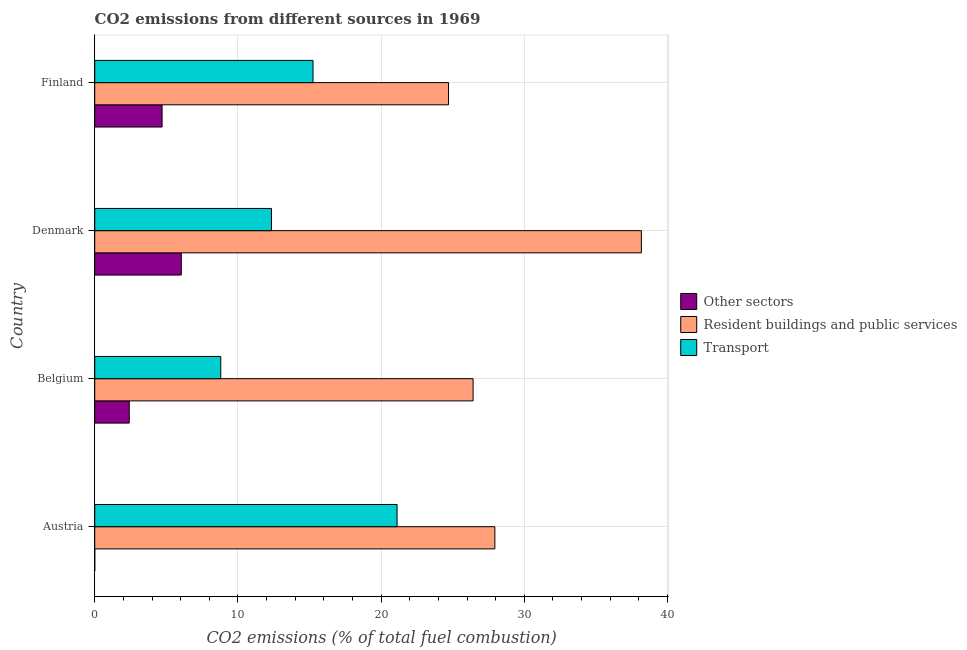How many different coloured bars are there?
Provide a short and direct response. 3. How many groups of bars are there?
Offer a very short reply. 4. What is the label of the 1st group of bars from the top?
Give a very brief answer. Finland. In how many cases, is the number of bars for a given country not equal to the number of legend labels?
Your answer should be compact. 1. What is the percentage of co2 emissions from other sectors in Finland?
Give a very brief answer. 4.7. Across all countries, what is the maximum percentage of co2 emissions from resident buildings and public services?
Make the answer very short. 38.18. Across all countries, what is the minimum percentage of co2 emissions from other sectors?
Offer a terse response. 0. What is the total percentage of co2 emissions from transport in the graph?
Your answer should be very brief. 57.51. What is the difference between the percentage of co2 emissions from resident buildings and public services in Denmark and that in Finland?
Your answer should be compact. 13.47. What is the difference between the percentage of co2 emissions from transport in Austria and the percentage of co2 emissions from resident buildings and public services in Denmark?
Keep it short and to the point. -17.06. What is the average percentage of co2 emissions from other sectors per country?
Provide a succinct answer. 3.29. What is the difference between the percentage of co2 emissions from other sectors and percentage of co2 emissions from resident buildings and public services in Belgium?
Ensure brevity in your answer.  -24.01. In how many countries, is the percentage of co2 emissions from other sectors greater than 26 %?
Offer a terse response. 0. What is the ratio of the percentage of co2 emissions from resident buildings and public services in Austria to that in Finland?
Ensure brevity in your answer.  1.13. Is the percentage of co2 emissions from transport in Austria less than that in Finland?
Make the answer very short. No. What is the difference between the highest and the second highest percentage of co2 emissions from other sectors?
Your response must be concise. 1.34. What is the difference between the highest and the lowest percentage of co2 emissions from resident buildings and public services?
Give a very brief answer. 13.47. In how many countries, is the percentage of co2 emissions from resident buildings and public services greater than the average percentage of co2 emissions from resident buildings and public services taken over all countries?
Your answer should be compact. 1. Is the sum of the percentage of co2 emissions from resident buildings and public services in Denmark and Finland greater than the maximum percentage of co2 emissions from transport across all countries?
Your response must be concise. Yes. Is it the case that in every country, the sum of the percentage of co2 emissions from other sectors and percentage of co2 emissions from resident buildings and public services is greater than the percentage of co2 emissions from transport?
Keep it short and to the point. Yes. How many bars are there?
Your response must be concise. 11. Are all the bars in the graph horizontal?
Provide a short and direct response. Yes. Are the values on the major ticks of X-axis written in scientific E-notation?
Provide a short and direct response. No. Does the graph contain any zero values?
Offer a very short reply. Yes. Does the graph contain grids?
Make the answer very short. Yes. Where does the legend appear in the graph?
Make the answer very short. Center right. What is the title of the graph?
Your answer should be very brief. CO2 emissions from different sources in 1969. What is the label or title of the X-axis?
Offer a very short reply. CO2 emissions (% of total fuel combustion). What is the label or title of the Y-axis?
Your answer should be compact. Country. What is the CO2 emissions (% of total fuel combustion) in Other sectors in Austria?
Make the answer very short. 0. What is the CO2 emissions (% of total fuel combustion) in Resident buildings and public services in Austria?
Your response must be concise. 27.94. What is the CO2 emissions (% of total fuel combustion) in Transport in Austria?
Offer a very short reply. 21.11. What is the CO2 emissions (% of total fuel combustion) in Other sectors in Belgium?
Offer a terse response. 2.41. What is the CO2 emissions (% of total fuel combustion) of Resident buildings and public services in Belgium?
Your answer should be compact. 26.42. What is the CO2 emissions (% of total fuel combustion) of Transport in Belgium?
Make the answer very short. 8.8. What is the CO2 emissions (% of total fuel combustion) in Other sectors in Denmark?
Offer a terse response. 6.05. What is the CO2 emissions (% of total fuel combustion) in Resident buildings and public services in Denmark?
Your response must be concise. 38.18. What is the CO2 emissions (% of total fuel combustion) of Transport in Denmark?
Keep it short and to the point. 12.34. What is the CO2 emissions (% of total fuel combustion) in Other sectors in Finland?
Offer a terse response. 4.7. What is the CO2 emissions (% of total fuel combustion) of Resident buildings and public services in Finland?
Give a very brief answer. 24.71. What is the CO2 emissions (% of total fuel combustion) in Transport in Finland?
Give a very brief answer. 15.25. Across all countries, what is the maximum CO2 emissions (% of total fuel combustion) in Other sectors?
Your response must be concise. 6.05. Across all countries, what is the maximum CO2 emissions (% of total fuel combustion) of Resident buildings and public services?
Provide a short and direct response. 38.18. Across all countries, what is the maximum CO2 emissions (% of total fuel combustion) of Transport?
Keep it short and to the point. 21.11. Across all countries, what is the minimum CO2 emissions (% of total fuel combustion) in Resident buildings and public services?
Ensure brevity in your answer.  24.71. Across all countries, what is the minimum CO2 emissions (% of total fuel combustion) of Transport?
Your response must be concise. 8.8. What is the total CO2 emissions (% of total fuel combustion) in Other sectors in the graph?
Keep it short and to the point. 13.16. What is the total CO2 emissions (% of total fuel combustion) in Resident buildings and public services in the graph?
Give a very brief answer. 117.26. What is the total CO2 emissions (% of total fuel combustion) of Transport in the graph?
Your answer should be very brief. 57.51. What is the difference between the CO2 emissions (% of total fuel combustion) of Resident buildings and public services in Austria and that in Belgium?
Keep it short and to the point. 1.52. What is the difference between the CO2 emissions (% of total fuel combustion) in Transport in Austria and that in Belgium?
Provide a short and direct response. 12.31. What is the difference between the CO2 emissions (% of total fuel combustion) in Resident buildings and public services in Austria and that in Denmark?
Your response must be concise. -10.23. What is the difference between the CO2 emissions (% of total fuel combustion) in Transport in Austria and that in Denmark?
Offer a very short reply. 8.77. What is the difference between the CO2 emissions (% of total fuel combustion) of Resident buildings and public services in Austria and that in Finland?
Ensure brevity in your answer.  3.23. What is the difference between the CO2 emissions (% of total fuel combustion) in Transport in Austria and that in Finland?
Make the answer very short. 5.87. What is the difference between the CO2 emissions (% of total fuel combustion) in Other sectors in Belgium and that in Denmark?
Offer a very short reply. -3.63. What is the difference between the CO2 emissions (% of total fuel combustion) of Resident buildings and public services in Belgium and that in Denmark?
Provide a succinct answer. -11.75. What is the difference between the CO2 emissions (% of total fuel combustion) in Transport in Belgium and that in Denmark?
Make the answer very short. -3.54. What is the difference between the CO2 emissions (% of total fuel combustion) in Other sectors in Belgium and that in Finland?
Provide a succinct answer. -2.29. What is the difference between the CO2 emissions (% of total fuel combustion) in Resident buildings and public services in Belgium and that in Finland?
Your answer should be very brief. 1.72. What is the difference between the CO2 emissions (% of total fuel combustion) of Transport in Belgium and that in Finland?
Offer a very short reply. -6.44. What is the difference between the CO2 emissions (% of total fuel combustion) of Other sectors in Denmark and that in Finland?
Ensure brevity in your answer.  1.34. What is the difference between the CO2 emissions (% of total fuel combustion) of Resident buildings and public services in Denmark and that in Finland?
Your answer should be compact. 13.47. What is the difference between the CO2 emissions (% of total fuel combustion) in Transport in Denmark and that in Finland?
Make the answer very short. -2.9. What is the difference between the CO2 emissions (% of total fuel combustion) in Resident buildings and public services in Austria and the CO2 emissions (% of total fuel combustion) in Transport in Belgium?
Offer a terse response. 19.14. What is the difference between the CO2 emissions (% of total fuel combustion) in Resident buildings and public services in Austria and the CO2 emissions (% of total fuel combustion) in Transport in Denmark?
Your answer should be compact. 15.6. What is the difference between the CO2 emissions (% of total fuel combustion) in Resident buildings and public services in Austria and the CO2 emissions (% of total fuel combustion) in Transport in Finland?
Ensure brevity in your answer.  12.7. What is the difference between the CO2 emissions (% of total fuel combustion) in Other sectors in Belgium and the CO2 emissions (% of total fuel combustion) in Resident buildings and public services in Denmark?
Your answer should be compact. -35.77. What is the difference between the CO2 emissions (% of total fuel combustion) of Other sectors in Belgium and the CO2 emissions (% of total fuel combustion) of Transport in Denmark?
Your answer should be very brief. -9.93. What is the difference between the CO2 emissions (% of total fuel combustion) in Resident buildings and public services in Belgium and the CO2 emissions (% of total fuel combustion) in Transport in Denmark?
Provide a succinct answer. 14.08. What is the difference between the CO2 emissions (% of total fuel combustion) of Other sectors in Belgium and the CO2 emissions (% of total fuel combustion) of Resident buildings and public services in Finland?
Provide a succinct answer. -22.3. What is the difference between the CO2 emissions (% of total fuel combustion) of Other sectors in Belgium and the CO2 emissions (% of total fuel combustion) of Transport in Finland?
Your answer should be compact. -12.84. What is the difference between the CO2 emissions (% of total fuel combustion) of Resident buildings and public services in Belgium and the CO2 emissions (% of total fuel combustion) of Transport in Finland?
Your answer should be very brief. 11.18. What is the difference between the CO2 emissions (% of total fuel combustion) in Other sectors in Denmark and the CO2 emissions (% of total fuel combustion) in Resident buildings and public services in Finland?
Your response must be concise. -18.66. What is the difference between the CO2 emissions (% of total fuel combustion) of Other sectors in Denmark and the CO2 emissions (% of total fuel combustion) of Transport in Finland?
Provide a succinct answer. -9.2. What is the difference between the CO2 emissions (% of total fuel combustion) in Resident buildings and public services in Denmark and the CO2 emissions (% of total fuel combustion) in Transport in Finland?
Offer a terse response. 22.93. What is the average CO2 emissions (% of total fuel combustion) in Other sectors per country?
Provide a short and direct response. 3.29. What is the average CO2 emissions (% of total fuel combustion) of Resident buildings and public services per country?
Your answer should be very brief. 29.31. What is the average CO2 emissions (% of total fuel combustion) of Transport per country?
Give a very brief answer. 14.38. What is the difference between the CO2 emissions (% of total fuel combustion) of Resident buildings and public services and CO2 emissions (% of total fuel combustion) of Transport in Austria?
Keep it short and to the point. 6.83. What is the difference between the CO2 emissions (% of total fuel combustion) in Other sectors and CO2 emissions (% of total fuel combustion) in Resident buildings and public services in Belgium?
Your answer should be very brief. -24.01. What is the difference between the CO2 emissions (% of total fuel combustion) in Other sectors and CO2 emissions (% of total fuel combustion) in Transport in Belgium?
Keep it short and to the point. -6.39. What is the difference between the CO2 emissions (% of total fuel combustion) in Resident buildings and public services and CO2 emissions (% of total fuel combustion) in Transport in Belgium?
Offer a terse response. 17.62. What is the difference between the CO2 emissions (% of total fuel combustion) of Other sectors and CO2 emissions (% of total fuel combustion) of Resident buildings and public services in Denmark?
Give a very brief answer. -32.13. What is the difference between the CO2 emissions (% of total fuel combustion) in Other sectors and CO2 emissions (% of total fuel combustion) in Transport in Denmark?
Provide a short and direct response. -6.3. What is the difference between the CO2 emissions (% of total fuel combustion) in Resident buildings and public services and CO2 emissions (% of total fuel combustion) in Transport in Denmark?
Offer a terse response. 25.83. What is the difference between the CO2 emissions (% of total fuel combustion) in Other sectors and CO2 emissions (% of total fuel combustion) in Resident buildings and public services in Finland?
Provide a succinct answer. -20.01. What is the difference between the CO2 emissions (% of total fuel combustion) of Other sectors and CO2 emissions (% of total fuel combustion) of Transport in Finland?
Your response must be concise. -10.54. What is the difference between the CO2 emissions (% of total fuel combustion) in Resident buildings and public services and CO2 emissions (% of total fuel combustion) in Transport in Finland?
Your answer should be compact. 9.46. What is the ratio of the CO2 emissions (% of total fuel combustion) in Resident buildings and public services in Austria to that in Belgium?
Make the answer very short. 1.06. What is the ratio of the CO2 emissions (% of total fuel combustion) in Transport in Austria to that in Belgium?
Offer a terse response. 2.4. What is the ratio of the CO2 emissions (% of total fuel combustion) in Resident buildings and public services in Austria to that in Denmark?
Your answer should be compact. 0.73. What is the ratio of the CO2 emissions (% of total fuel combustion) in Transport in Austria to that in Denmark?
Ensure brevity in your answer.  1.71. What is the ratio of the CO2 emissions (% of total fuel combustion) of Resident buildings and public services in Austria to that in Finland?
Give a very brief answer. 1.13. What is the ratio of the CO2 emissions (% of total fuel combustion) of Transport in Austria to that in Finland?
Provide a short and direct response. 1.38. What is the ratio of the CO2 emissions (% of total fuel combustion) in Other sectors in Belgium to that in Denmark?
Make the answer very short. 0.4. What is the ratio of the CO2 emissions (% of total fuel combustion) in Resident buildings and public services in Belgium to that in Denmark?
Offer a terse response. 0.69. What is the ratio of the CO2 emissions (% of total fuel combustion) of Transport in Belgium to that in Denmark?
Your answer should be very brief. 0.71. What is the ratio of the CO2 emissions (% of total fuel combustion) in Other sectors in Belgium to that in Finland?
Keep it short and to the point. 0.51. What is the ratio of the CO2 emissions (% of total fuel combustion) of Resident buildings and public services in Belgium to that in Finland?
Keep it short and to the point. 1.07. What is the ratio of the CO2 emissions (% of total fuel combustion) of Transport in Belgium to that in Finland?
Ensure brevity in your answer.  0.58. What is the ratio of the CO2 emissions (% of total fuel combustion) of Other sectors in Denmark to that in Finland?
Your answer should be very brief. 1.29. What is the ratio of the CO2 emissions (% of total fuel combustion) in Resident buildings and public services in Denmark to that in Finland?
Provide a succinct answer. 1.54. What is the ratio of the CO2 emissions (% of total fuel combustion) of Transport in Denmark to that in Finland?
Ensure brevity in your answer.  0.81. What is the difference between the highest and the second highest CO2 emissions (% of total fuel combustion) of Other sectors?
Provide a succinct answer. 1.34. What is the difference between the highest and the second highest CO2 emissions (% of total fuel combustion) of Resident buildings and public services?
Your answer should be very brief. 10.23. What is the difference between the highest and the second highest CO2 emissions (% of total fuel combustion) in Transport?
Your response must be concise. 5.87. What is the difference between the highest and the lowest CO2 emissions (% of total fuel combustion) in Other sectors?
Keep it short and to the point. 6.05. What is the difference between the highest and the lowest CO2 emissions (% of total fuel combustion) in Resident buildings and public services?
Offer a terse response. 13.47. What is the difference between the highest and the lowest CO2 emissions (% of total fuel combustion) of Transport?
Offer a terse response. 12.31. 